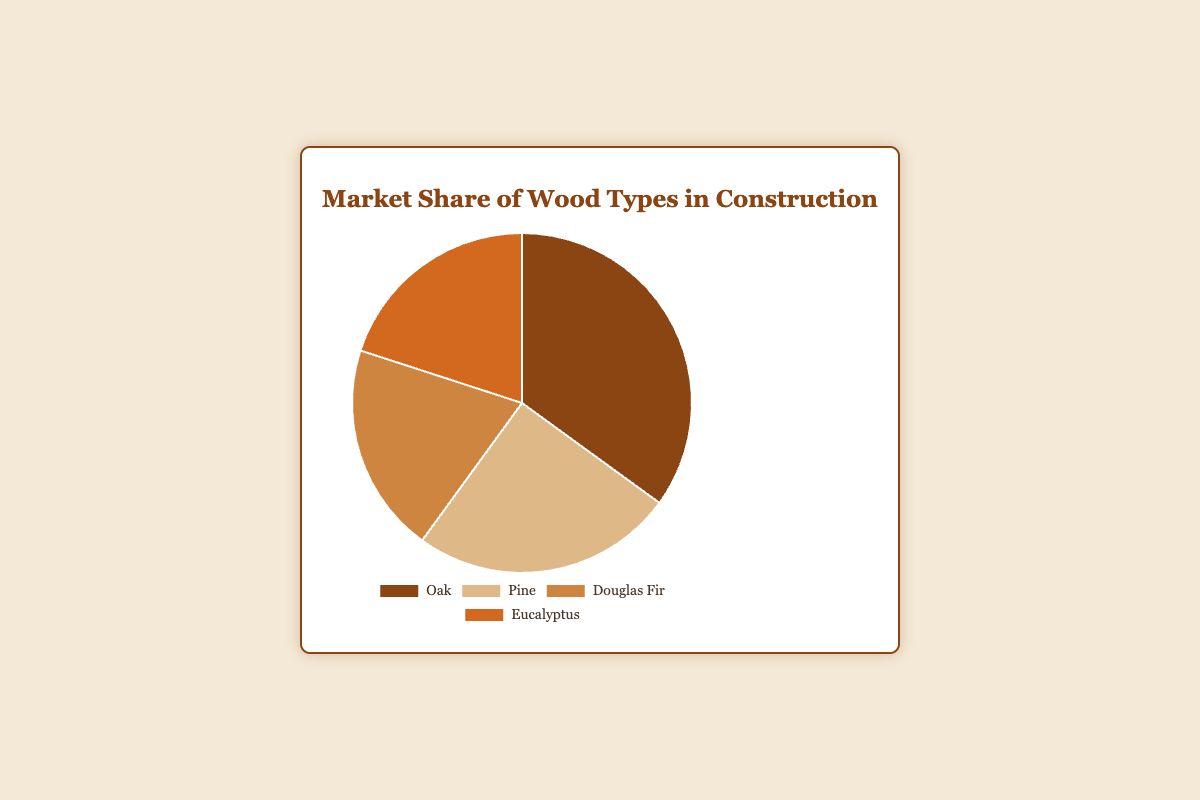What is the market share percentage of Pine? Refer to the pie chart section labeled "Pine" to find its market share percentage. The label indicates that Pine has a market share of 25%.
Answer: 25% Which wood type has the largest market share? Look at the pie chart and identify the wood type with the largest slice. The section labeled "Oak" is the largest, indicating it has the highest market share percentage at 35%.
Answer: Oak How does the market share of Oak compare to that of Eucalyptus? Compare the sizes of the pie chart sections for Oak and Eucalyptus. Oak has a market share of 35%, while Eucalyptus has 20%. Since 35% is greater than 20%, Oak has a larger market share than Eucalyptus.
Answer: Oak has a larger market share What is the cumulative market share of Douglas Fir and Eucalyptus? Add the market share percentages of Douglas Fir and Eucalyptus. Both have a market share of 20%, so 20% + 20% = 40%.
Answer: 40% Which wood types have an equal market share percentage? Look for wood types with the same market share percentage values. Douglas Fir and Eucalyptus both have a market share of 20%.
Answer: Douglas Fir and Eucalyptus By how much does Oak's market share exceed Pine's market share? Subtract Pine's market share percentage (25%) from Oak's market share percentage (35%). So, 35% - 25% = 10%.
Answer: 10% Which wood type has the smallest market share? Identify the smallest slice on the pie chart. Douglas Fir and Eucalyptus are tied for the smallest market share at 20% each.
Answer: Douglas Fir and Eucalyptus What portion of the total market share is accounted for by fast-growing trees like Pine and Eucalyptus? Sum the market share percentages of Pine and Eucalyptus. Pine is at 25% and Eucalyptus is at 20%, so 25% + 20% = 45%.
Answer: 45% If Eucalyptus and Douglas Fir are combined into a single category, what would be its market share? Add the market share percentages of Eucalyptus and Douglas Fir. Both have 20%, so combined, they would have 20% + 20% = 40%.
Answer: 40% 